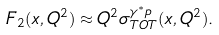Convert formula to latex. <formula><loc_0><loc_0><loc_500><loc_500>F _ { 2 } ( x , Q ^ { 2 } ) \approx Q ^ { 2 } \sigma _ { T O T } ^ { \gamma ^ { \ast } p } ( x , Q ^ { 2 } ) .</formula> 